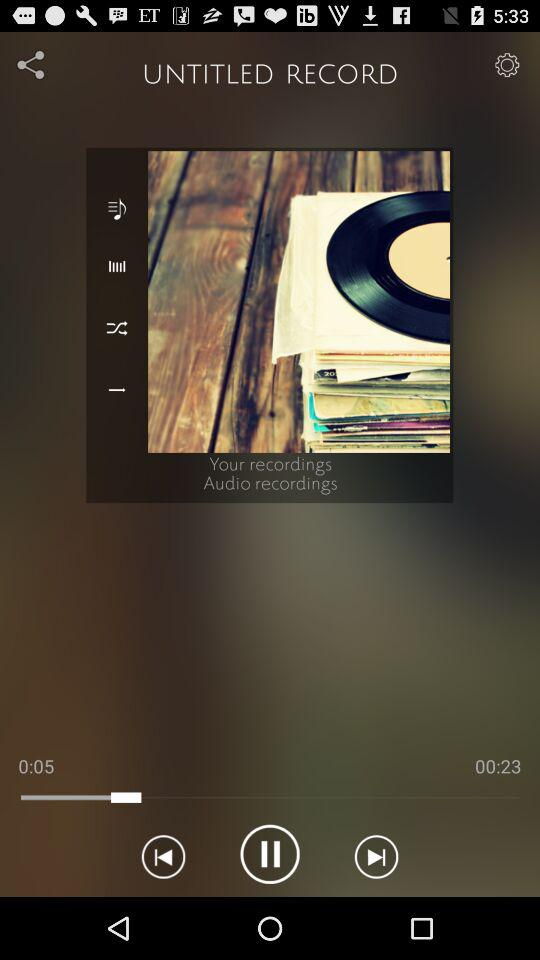How long has the audio been playing? The audio has been playing for 5 seconds. 